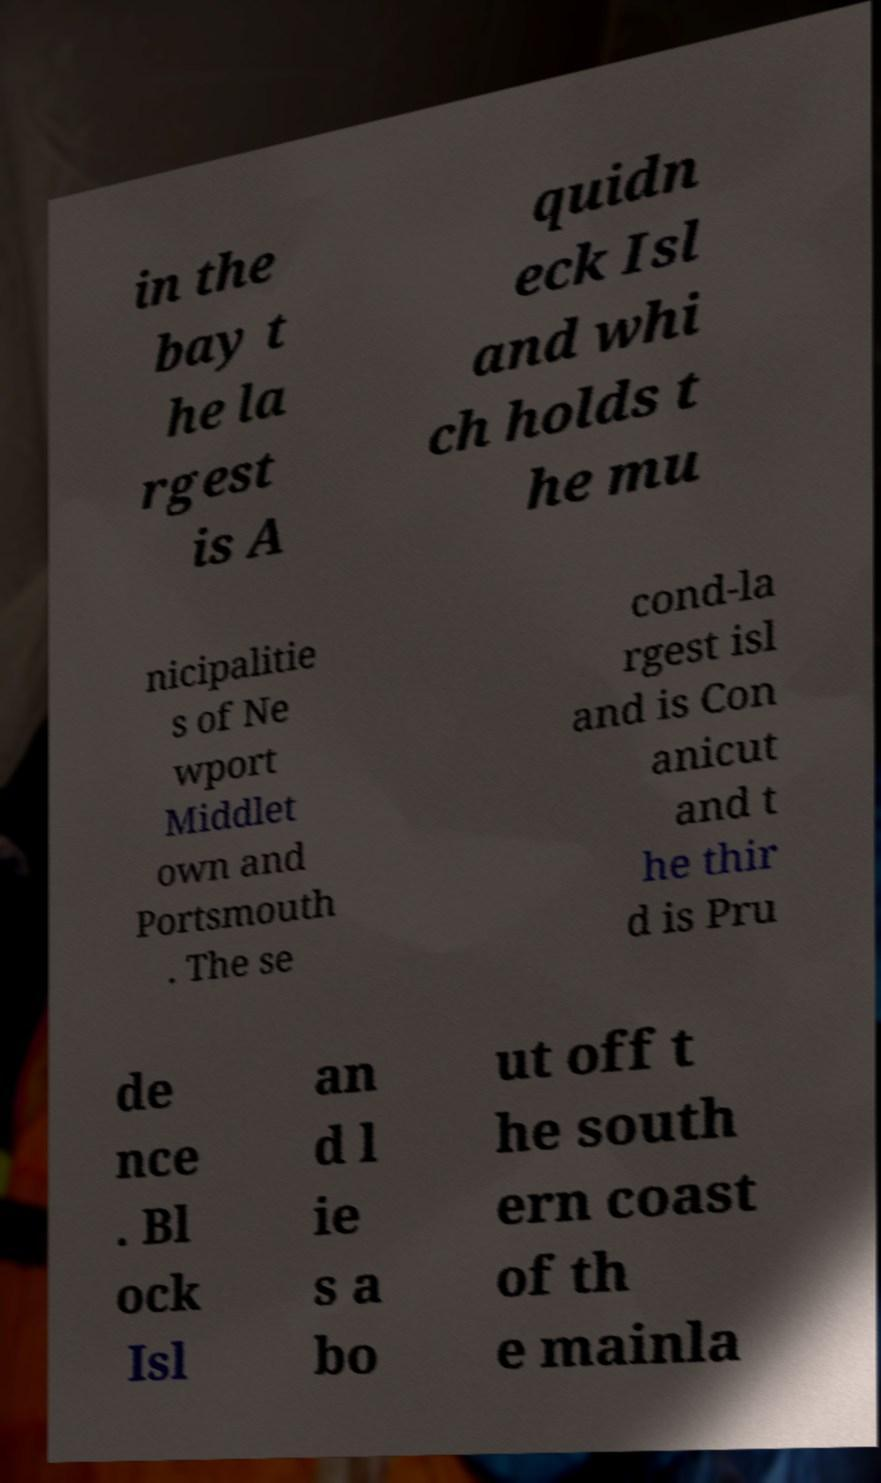Please identify and transcribe the text found in this image. in the bay t he la rgest is A quidn eck Isl and whi ch holds t he mu nicipalitie s of Ne wport Middlet own and Portsmouth . The se cond-la rgest isl and is Con anicut and t he thir d is Pru de nce . Bl ock Isl an d l ie s a bo ut off t he south ern coast of th e mainla 